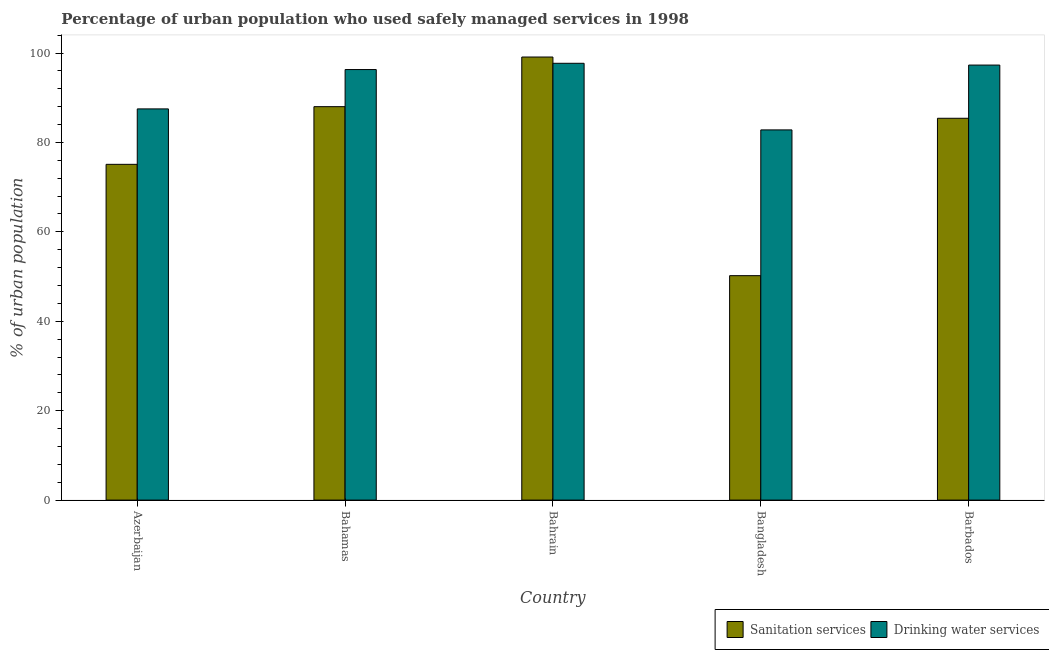How many groups of bars are there?
Provide a short and direct response. 5. Are the number of bars per tick equal to the number of legend labels?
Provide a short and direct response. Yes. Are the number of bars on each tick of the X-axis equal?
Your response must be concise. Yes. How many bars are there on the 4th tick from the left?
Your answer should be compact. 2. How many bars are there on the 1st tick from the right?
Offer a very short reply. 2. What is the label of the 5th group of bars from the left?
Make the answer very short. Barbados. Across all countries, what is the maximum percentage of urban population who used drinking water services?
Make the answer very short. 97.7. Across all countries, what is the minimum percentage of urban population who used sanitation services?
Offer a very short reply. 50.2. In which country was the percentage of urban population who used drinking water services maximum?
Make the answer very short. Bahrain. In which country was the percentage of urban population who used sanitation services minimum?
Your answer should be compact. Bangladesh. What is the total percentage of urban population who used drinking water services in the graph?
Provide a succinct answer. 461.6. What is the difference between the percentage of urban population who used sanitation services in Bahrain and that in Barbados?
Ensure brevity in your answer.  13.7. What is the difference between the percentage of urban population who used sanitation services in Bangladesh and the percentage of urban population who used drinking water services in Barbados?
Provide a succinct answer. -47.1. What is the average percentage of urban population who used sanitation services per country?
Offer a very short reply. 79.56. What is the difference between the percentage of urban population who used sanitation services and percentage of urban population who used drinking water services in Bahamas?
Make the answer very short. -8.3. In how many countries, is the percentage of urban population who used sanitation services greater than 16 %?
Give a very brief answer. 5. What is the ratio of the percentage of urban population who used sanitation services in Azerbaijan to that in Bahrain?
Your answer should be very brief. 0.76. Is the percentage of urban population who used drinking water services in Bahrain less than that in Barbados?
Your answer should be compact. No. Is the difference between the percentage of urban population who used sanitation services in Azerbaijan and Barbados greater than the difference between the percentage of urban population who used drinking water services in Azerbaijan and Barbados?
Provide a succinct answer. No. What is the difference between the highest and the second highest percentage of urban population who used sanitation services?
Provide a succinct answer. 11.1. What is the difference between the highest and the lowest percentage of urban population who used drinking water services?
Offer a very short reply. 14.9. Is the sum of the percentage of urban population who used drinking water services in Bahrain and Bangladesh greater than the maximum percentage of urban population who used sanitation services across all countries?
Your answer should be very brief. Yes. What does the 1st bar from the left in Azerbaijan represents?
Your response must be concise. Sanitation services. What does the 1st bar from the right in Bahamas represents?
Your answer should be compact. Drinking water services. How many bars are there?
Provide a succinct answer. 10. Are all the bars in the graph horizontal?
Make the answer very short. No. What is the difference between two consecutive major ticks on the Y-axis?
Your response must be concise. 20. Does the graph contain grids?
Your response must be concise. No. Where does the legend appear in the graph?
Your answer should be compact. Bottom right. How are the legend labels stacked?
Keep it short and to the point. Horizontal. What is the title of the graph?
Your response must be concise. Percentage of urban population who used safely managed services in 1998. Does "Residents" appear as one of the legend labels in the graph?
Give a very brief answer. No. What is the label or title of the X-axis?
Make the answer very short. Country. What is the label or title of the Y-axis?
Your answer should be very brief. % of urban population. What is the % of urban population in Sanitation services in Azerbaijan?
Ensure brevity in your answer.  75.1. What is the % of urban population in Drinking water services in Azerbaijan?
Make the answer very short. 87.5. What is the % of urban population of Sanitation services in Bahamas?
Your answer should be very brief. 88. What is the % of urban population in Drinking water services in Bahamas?
Keep it short and to the point. 96.3. What is the % of urban population in Sanitation services in Bahrain?
Offer a very short reply. 99.1. What is the % of urban population in Drinking water services in Bahrain?
Give a very brief answer. 97.7. What is the % of urban population in Sanitation services in Bangladesh?
Give a very brief answer. 50.2. What is the % of urban population in Drinking water services in Bangladesh?
Offer a terse response. 82.8. What is the % of urban population of Sanitation services in Barbados?
Give a very brief answer. 85.4. What is the % of urban population of Drinking water services in Barbados?
Keep it short and to the point. 97.3. Across all countries, what is the maximum % of urban population in Sanitation services?
Provide a succinct answer. 99.1. Across all countries, what is the maximum % of urban population of Drinking water services?
Your response must be concise. 97.7. Across all countries, what is the minimum % of urban population in Sanitation services?
Give a very brief answer. 50.2. Across all countries, what is the minimum % of urban population of Drinking water services?
Offer a very short reply. 82.8. What is the total % of urban population in Sanitation services in the graph?
Offer a very short reply. 397.8. What is the total % of urban population in Drinking water services in the graph?
Offer a very short reply. 461.6. What is the difference between the % of urban population in Drinking water services in Azerbaijan and that in Bahrain?
Ensure brevity in your answer.  -10.2. What is the difference between the % of urban population of Sanitation services in Azerbaijan and that in Bangladesh?
Make the answer very short. 24.9. What is the difference between the % of urban population of Drinking water services in Azerbaijan and that in Bangladesh?
Keep it short and to the point. 4.7. What is the difference between the % of urban population of Sanitation services in Azerbaijan and that in Barbados?
Make the answer very short. -10.3. What is the difference between the % of urban population in Sanitation services in Bahamas and that in Bahrain?
Your answer should be very brief. -11.1. What is the difference between the % of urban population of Sanitation services in Bahamas and that in Bangladesh?
Offer a very short reply. 37.8. What is the difference between the % of urban population of Sanitation services in Bahamas and that in Barbados?
Your answer should be compact. 2.6. What is the difference between the % of urban population in Drinking water services in Bahamas and that in Barbados?
Your response must be concise. -1. What is the difference between the % of urban population in Sanitation services in Bahrain and that in Bangladesh?
Provide a succinct answer. 48.9. What is the difference between the % of urban population of Sanitation services in Bangladesh and that in Barbados?
Provide a short and direct response. -35.2. What is the difference between the % of urban population in Sanitation services in Azerbaijan and the % of urban population in Drinking water services in Bahamas?
Ensure brevity in your answer.  -21.2. What is the difference between the % of urban population in Sanitation services in Azerbaijan and the % of urban population in Drinking water services in Bahrain?
Provide a short and direct response. -22.6. What is the difference between the % of urban population of Sanitation services in Azerbaijan and the % of urban population of Drinking water services in Barbados?
Your response must be concise. -22.2. What is the difference between the % of urban population in Sanitation services in Bahamas and the % of urban population in Drinking water services in Barbados?
Keep it short and to the point. -9.3. What is the difference between the % of urban population of Sanitation services in Bangladesh and the % of urban population of Drinking water services in Barbados?
Your answer should be very brief. -47.1. What is the average % of urban population in Sanitation services per country?
Provide a short and direct response. 79.56. What is the average % of urban population of Drinking water services per country?
Offer a very short reply. 92.32. What is the difference between the % of urban population of Sanitation services and % of urban population of Drinking water services in Azerbaijan?
Ensure brevity in your answer.  -12.4. What is the difference between the % of urban population in Sanitation services and % of urban population in Drinking water services in Bahamas?
Provide a short and direct response. -8.3. What is the difference between the % of urban population of Sanitation services and % of urban population of Drinking water services in Bahrain?
Ensure brevity in your answer.  1.4. What is the difference between the % of urban population in Sanitation services and % of urban population in Drinking water services in Bangladesh?
Your answer should be compact. -32.6. What is the ratio of the % of urban population of Sanitation services in Azerbaijan to that in Bahamas?
Your response must be concise. 0.85. What is the ratio of the % of urban population in Drinking water services in Azerbaijan to that in Bahamas?
Provide a short and direct response. 0.91. What is the ratio of the % of urban population in Sanitation services in Azerbaijan to that in Bahrain?
Provide a short and direct response. 0.76. What is the ratio of the % of urban population in Drinking water services in Azerbaijan to that in Bahrain?
Your answer should be compact. 0.9. What is the ratio of the % of urban population of Sanitation services in Azerbaijan to that in Bangladesh?
Ensure brevity in your answer.  1.5. What is the ratio of the % of urban population in Drinking water services in Azerbaijan to that in Bangladesh?
Give a very brief answer. 1.06. What is the ratio of the % of urban population in Sanitation services in Azerbaijan to that in Barbados?
Provide a succinct answer. 0.88. What is the ratio of the % of urban population in Drinking water services in Azerbaijan to that in Barbados?
Provide a succinct answer. 0.9. What is the ratio of the % of urban population of Sanitation services in Bahamas to that in Bahrain?
Provide a succinct answer. 0.89. What is the ratio of the % of urban population of Drinking water services in Bahamas to that in Bahrain?
Offer a terse response. 0.99. What is the ratio of the % of urban population in Sanitation services in Bahamas to that in Bangladesh?
Your response must be concise. 1.75. What is the ratio of the % of urban population in Drinking water services in Bahamas to that in Bangladesh?
Ensure brevity in your answer.  1.16. What is the ratio of the % of urban population of Sanitation services in Bahamas to that in Barbados?
Offer a terse response. 1.03. What is the ratio of the % of urban population of Sanitation services in Bahrain to that in Bangladesh?
Ensure brevity in your answer.  1.97. What is the ratio of the % of urban population in Drinking water services in Bahrain to that in Bangladesh?
Provide a succinct answer. 1.18. What is the ratio of the % of urban population in Sanitation services in Bahrain to that in Barbados?
Ensure brevity in your answer.  1.16. What is the ratio of the % of urban population of Sanitation services in Bangladesh to that in Barbados?
Provide a succinct answer. 0.59. What is the ratio of the % of urban population in Drinking water services in Bangladesh to that in Barbados?
Make the answer very short. 0.85. What is the difference between the highest and the lowest % of urban population of Sanitation services?
Offer a terse response. 48.9. 